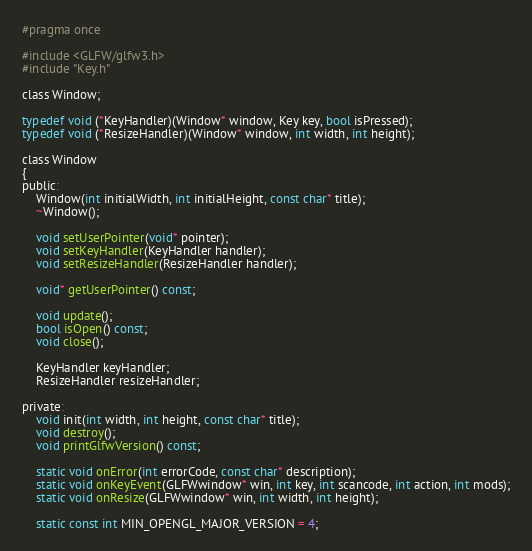Convert code to text. <code><loc_0><loc_0><loc_500><loc_500><_C_>#pragma once

#include <GLFW/glfw3.h>
#include "Key.h"

class Window;

typedef void (*KeyHandler)(Window* window, Key key, bool isPressed);
typedef void (*ResizeHandler)(Window* window, int width, int height);

class Window
{
public:
    Window(int initialWidth, int initialHeight, const char* title);
    ~Window();

    void setUserPointer(void* pointer);
    void setKeyHandler(KeyHandler handler);
    void setResizeHandler(ResizeHandler handler);

    void* getUserPointer() const;

    void update();
    bool isOpen() const;
    void close();

    KeyHandler keyHandler;
    ResizeHandler resizeHandler;

private:
    void init(int width, int height, const char* title);
    void destroy();
    void printGlfwVersion() const;

    static void onError(int errorCode, const char* description);
    static void onKeyEvent(GLFWwindow* win, int key, int scancode, int action, int mods);
    static void onResize(GLFWwindow* win, int width, int height);

    static const int MIN_OPENGL_MAJOR_VERSION = 4;</code> 